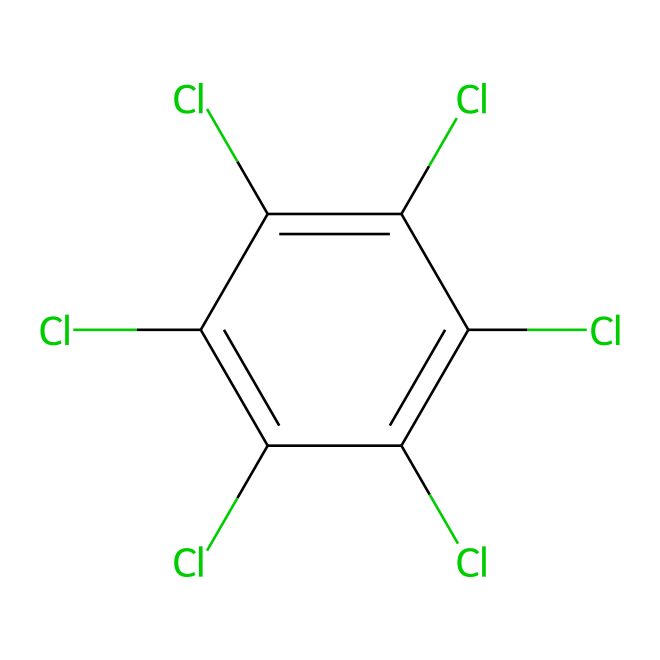What is the name of this chemical? The SMILES representation corresponds to chlorothalonil, which is a known fungicide. The specific arrangement of atoms and substituents in the structure is characteristic of chlorothalonil.
Answer: chlorothalonil How many chlorine atoms are present in the molecular structure? By analyzing the structure from the SMILES representation, there are five chlorine (Cl) atoms indicated in the chemical. Each 'Cl' in the representation corresponds to a chlorine atom attachable to different positions.
Answer: five What is the molecular formula of chlorothalonil? From the given structure, we can deduce the molecular formula by counting the atoms: C8 (for carbon), H4 (for hydrogen), and Cl5 (for chlorine). The formula can be represented as C8H4Cl5.
Answer: C8H4Cl5 How many double bonds are in the structure? The structure has two double bonds, evidenced by the '=' signs in the SMILES representation. Each '=' sign indicates a double bond between the connected atoms, showing where electrons are shared more than in a single bond.
Answer: two What type of chemical is chlorothalonil? Chlorothalonil belongs to the class of chemicals known as fungicides, specifically developed to prevent and control fungal diseases in crops and urban infrastructure.
Answer: fungicide Why is the presence of chlorine atoms significant in chlorothalonil? The chlorine atoms enhance the fungicidal properties of chlorothalonil by increasing its hydrophobic character and stability against degradation, which helps in its application on urban infrastructure to prevent fungal decay.
Answer: stability 